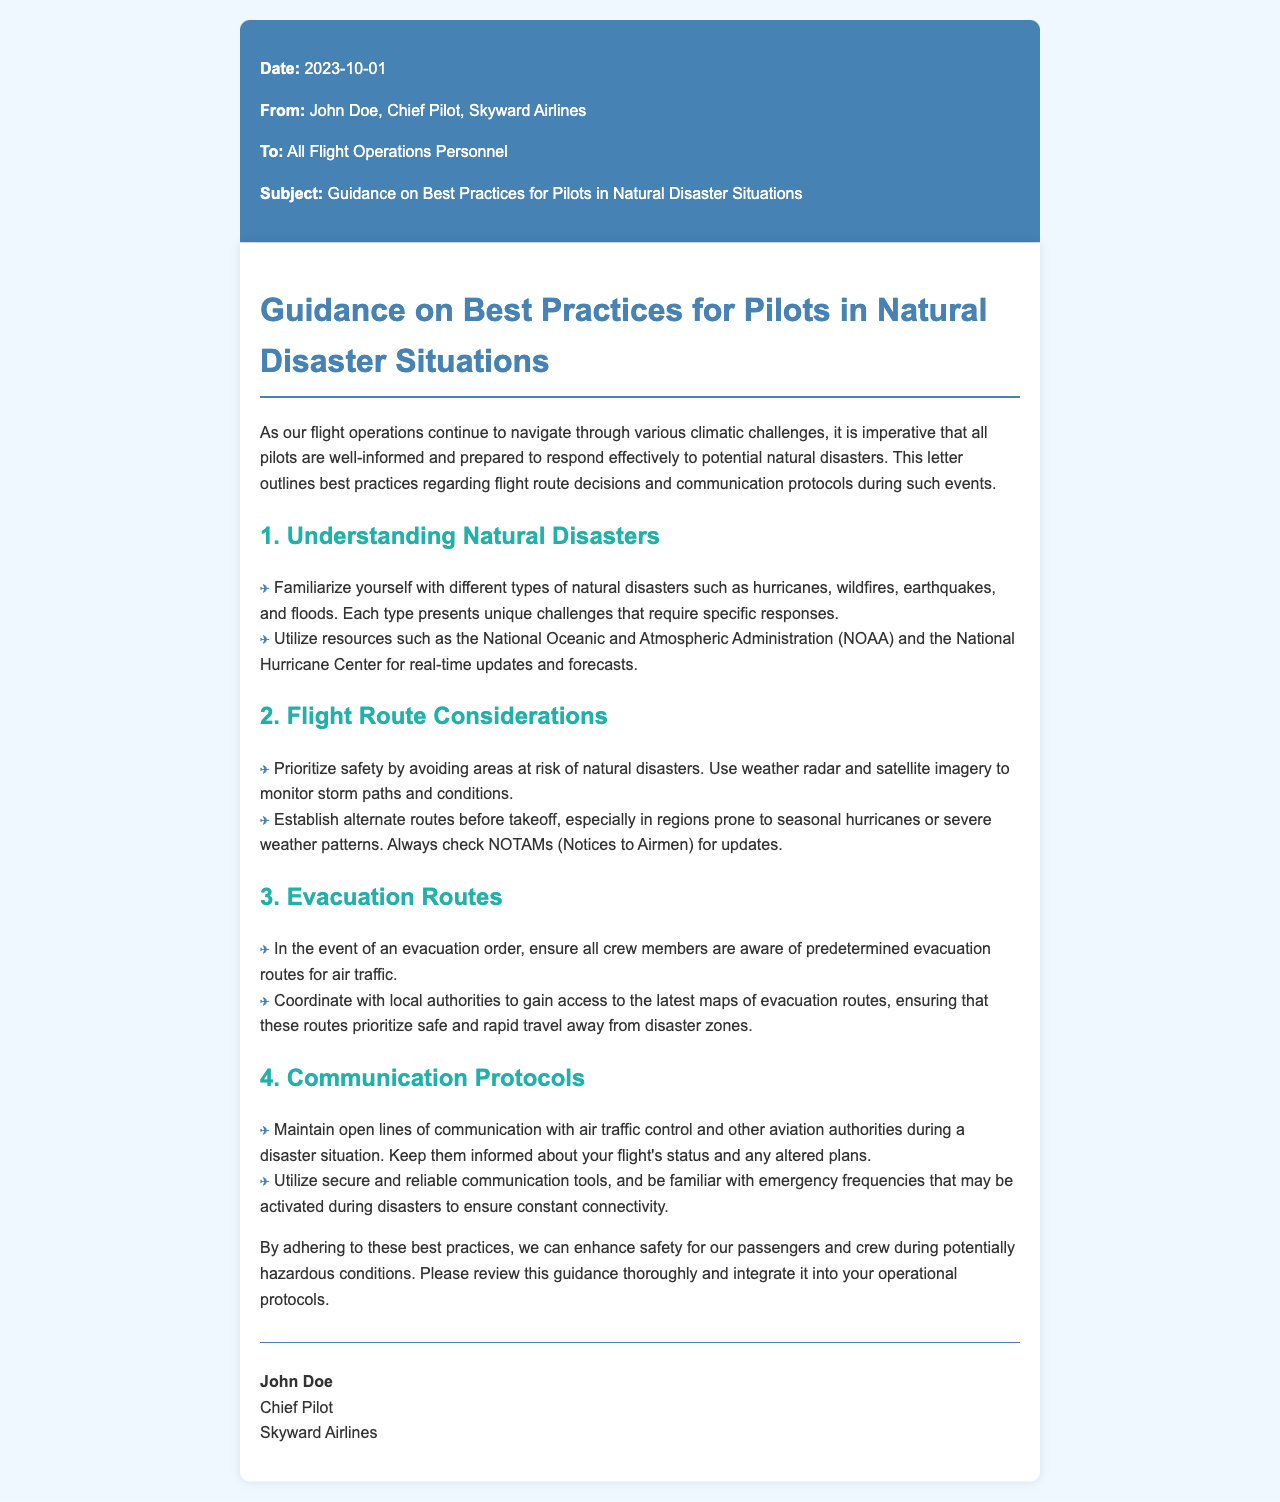What is the date of the letter? The date in the letter is explicitly mentioned as the date it was written and sent to the recipients.
Answer: 2023-10-01 Who is the Chief Pilot? The letter states the name of the individual holding the position of Chief Pilot at Skyward Airlines.
Answer: John Doe What types of natural disasters should pilots familiarize themselves with? The letter outlines several types of natural disasters that pilots should be aware of for proper preparation and response.
Answer: hurricanes, wildfires, earthquakes, floods What is prioritized for flight routes during natural disasters? The document emphasizes a specific key factor that must be considered when deciding on flight routes in the context of natural disasters.
Answer: safety What should pilots maintain with air traffic control? The letter highlights what type of communication is necessary for pilots to have with air traffic control during disaster situations.
Answer: open lines How should evacuation routes be determined? The guidance specifies that evacuation routes should be based on collaboration with external parties for best outcomes.
Answer: local authorities What is recommended to monitor storm paths? The document suggests a specific type of technology or resource to be used by pilots when monitoring potential storm impacts.
Answer: weather radar Should pilots review the guidance thoroughly? The last paragraph emphasizes the necessity of taking a specific action regarding the guidance presented in the letter.
Answer: Yes 